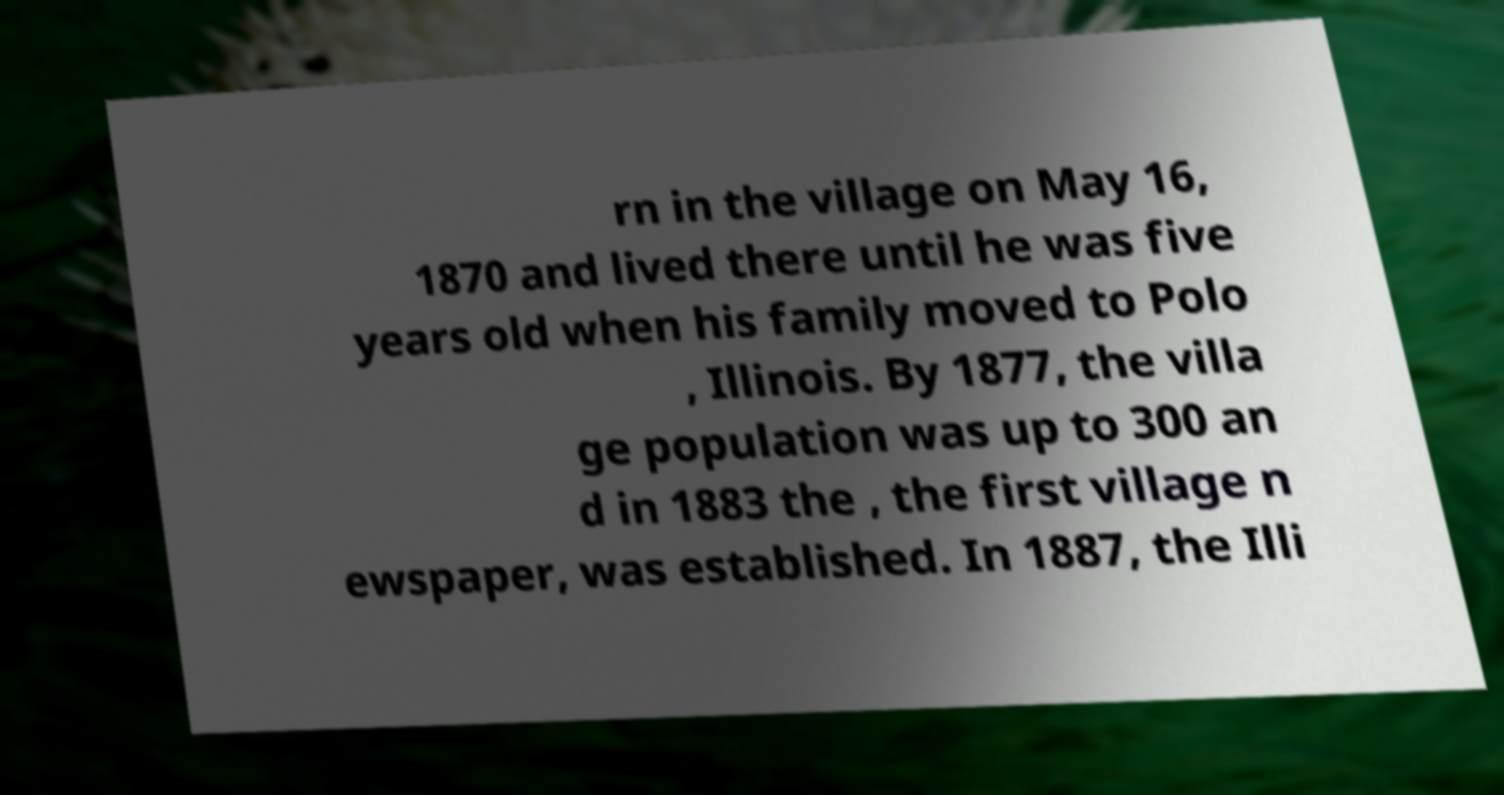For documentation purposes, I need the text within this image transcribed. Could you provide that? rn in the village on May 16, 1870 and lived there until he was five years old when his family moved to Polo , Illinois. By 1877, the villa ge population was up to 300 an d in 1883 the , the first village n ewspaper, was established. In 1887, the Illi 